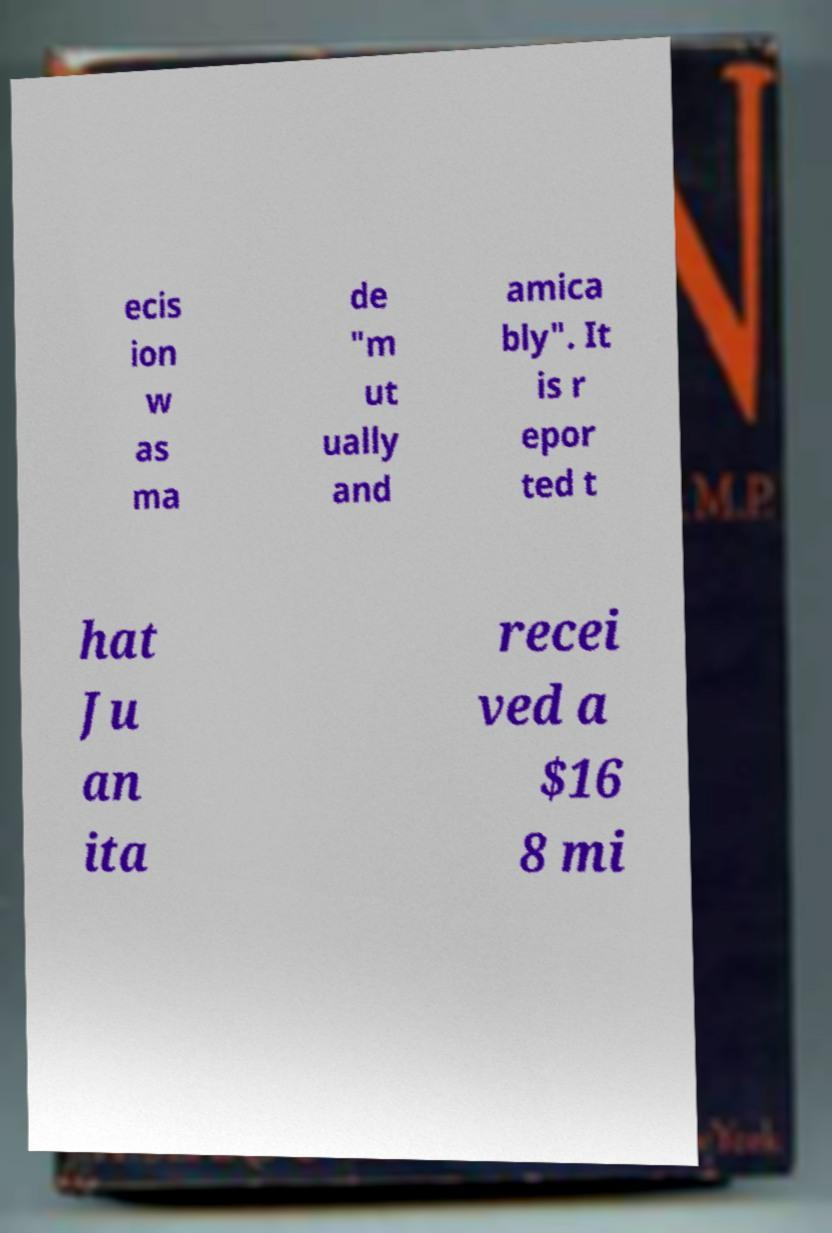For documentation purposes, I need the text within this image transcribed. Could you provide that? ecis ion w as ma de "m ut ually and amica bly". It is r epor ted t hat Ju an ita recei ved a $16 8 mi 